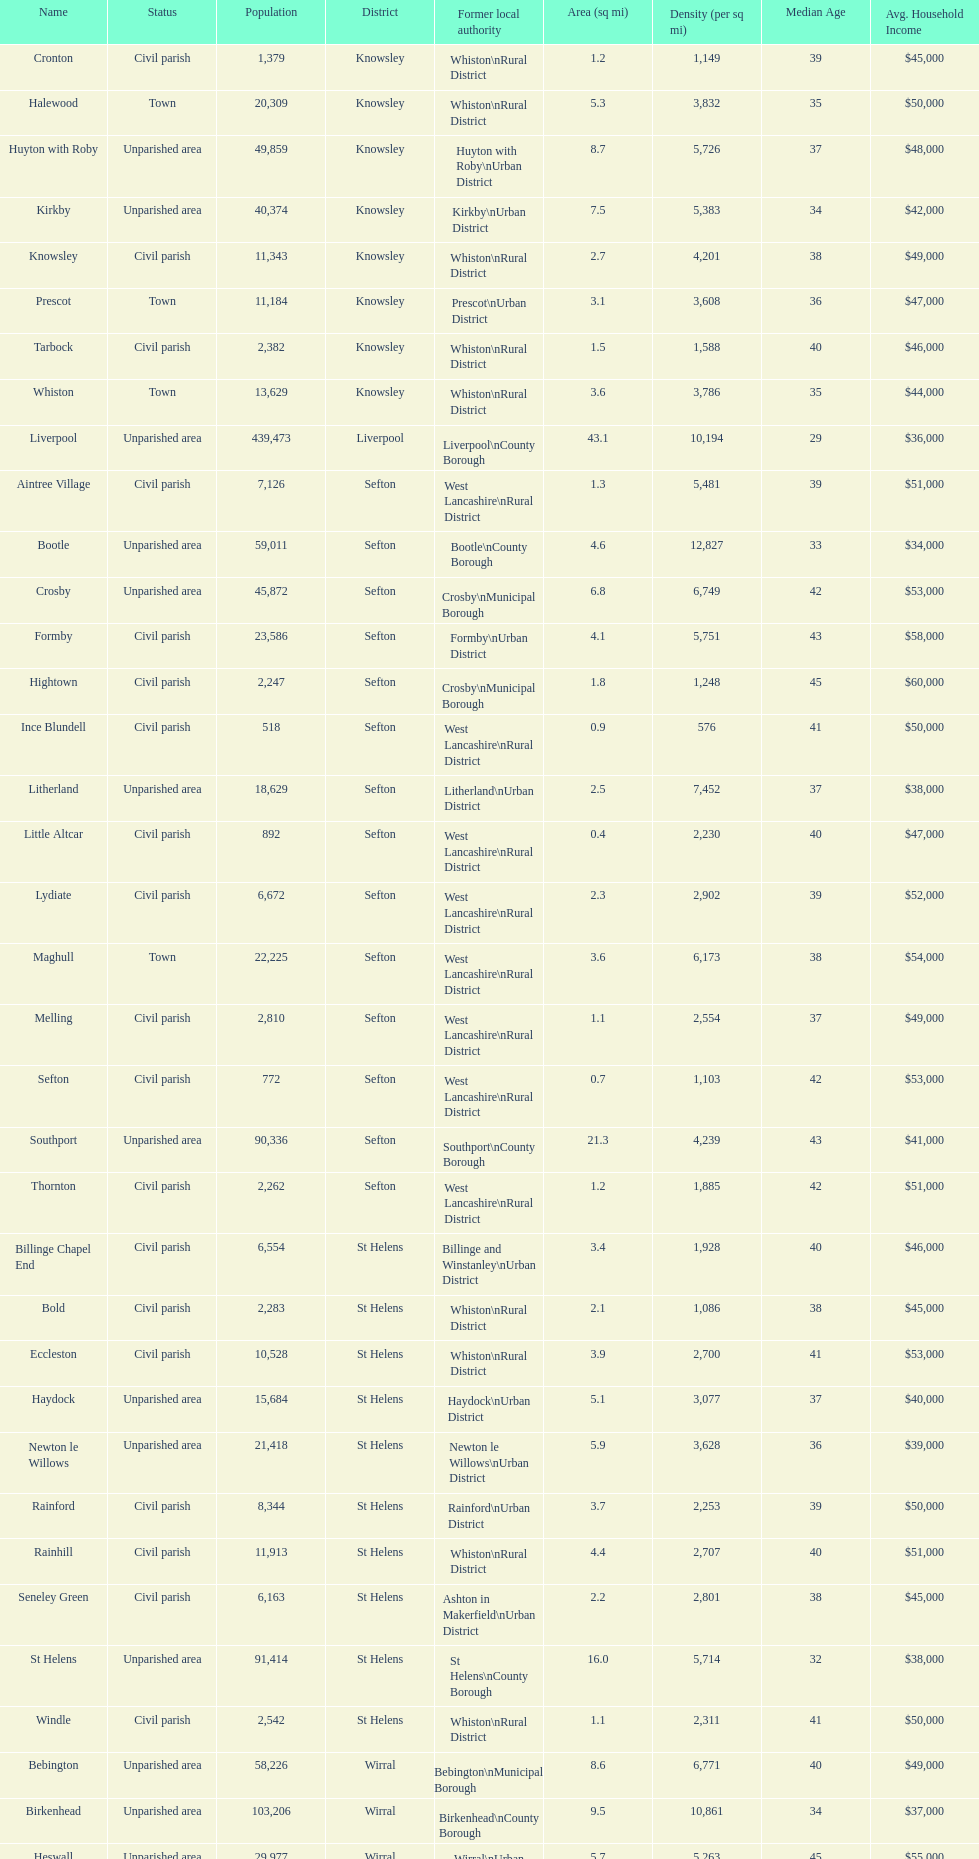Which is a civil parish, aintree village or maghull? Aintree Village. 